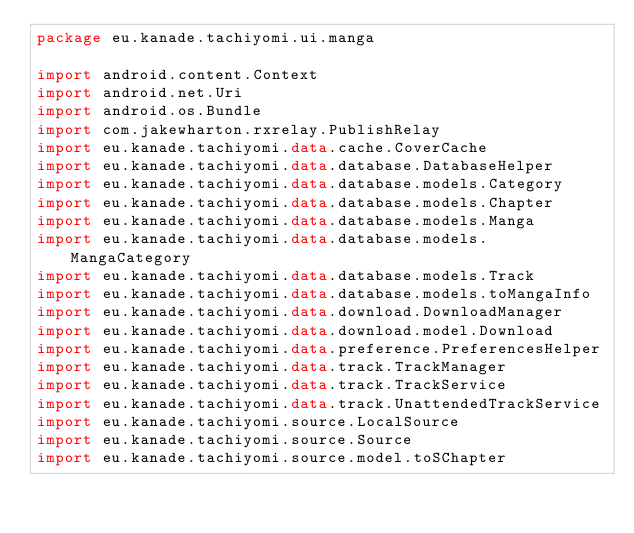Convert code to text. <code><loc_0><loc_0><loc_500><loc_500><_Kotlin_>package eu.kanade.tachiyomi.ui.manga

import android.content.Context
import android.net.Uri
import android.os.Bundle
import com.jakewharton.rxrelay.PublishRelay
import eu.kanade.tachiyomi.data.cache.CoverCache
import eu.kanade.tachiyomi.data.database.DatabaseHelper
import eu.kanade.tachiyomi.data.database.models.Category
import eu.kanade.tachiyomi.data.database.models.Chapter
import eu.kanade.tachiyomi.data.database.models.Manga
import eu.kanade.tachiyomi.data.database.models.MangaCategory
import eu.kanade.tachiyomi.data.database.models.Track
import eu.kanade.tachiyomi.data.database.models.toMangaInfo
import eu.kanade.tachiyomi.data.download.DownloadManager
import eu.kanade.tachiyomi.data.download.model.Download
import eu.kanade.tachiyomi.data.preference.PreferencesHelper
import eu.kanade.tachiyomi.data.track.TrackManager
import eu.kanade.tachiyomi.data.track.TrackService
import eu.kanade.tachiyomi.data.track.UnattendedTrackService
import eu.kanade.tachiyomi.source.LocalSource
import eu.kanade.tachiyomi.source.Source
import eu.kanade.tachiyomi.source.model.toSChapter</code> 